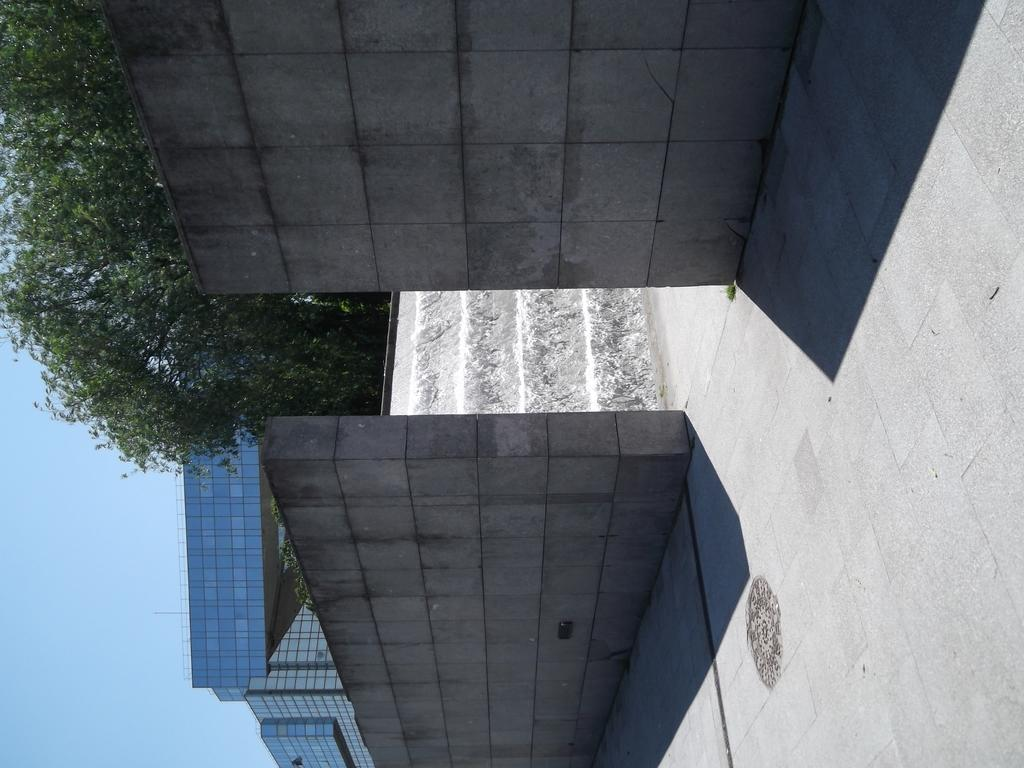What type of surface is visible in the image? There is a floor in the image. What surrounds the floor in the image? There are walls in the image. What can be seen in the distance in the image? There are trees, buildings, and the sky visible in the background of the image. Where is the goat grazing in the image? There is no goat present in the image. What type of road can be seen in the image? There is no road visible in the image. 